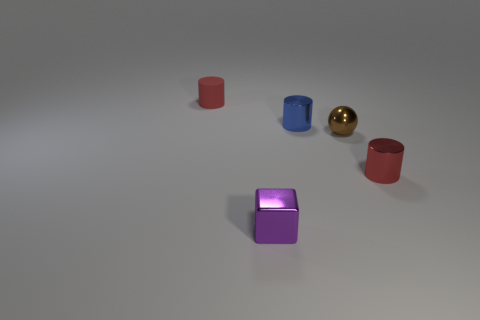Subtract all small metallic cylinders. How many cylinders are left? 1 Add 2 small brown balls. How many objects exist? 7 Subtract all balls. How many objects are left? 4 Subtract all brown cylinders. Subtract all green spheres. How many cylinders are left? 3 Add 3 tiny metal spheres. How many tiny metal spheres exist? 4 Subtract 0 yellow cylinders. How many objects are left? 5 Subtract all large gray cylinders. Subtract all tiny metal blocks. How many objects are left? 4 Add 1 small cylinders. How many small cylinders are left? 4 